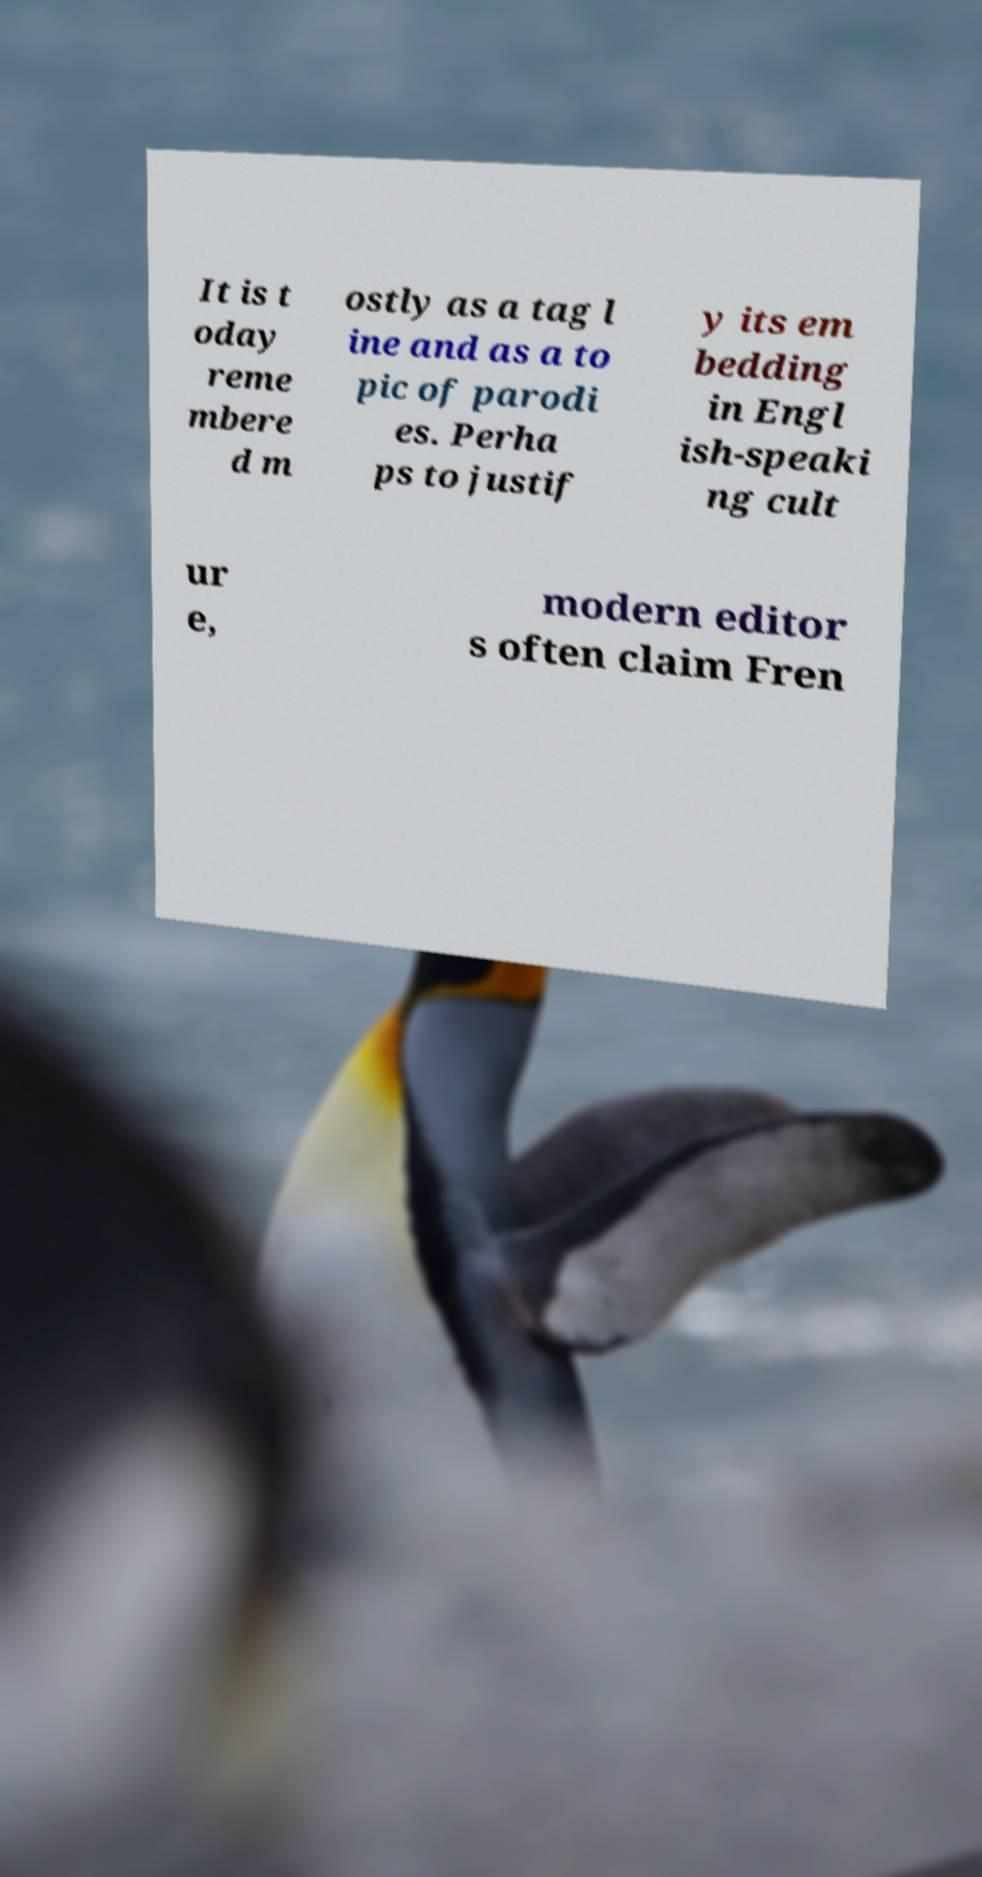Could you assist in decoding the text presented in this image and type it out clearly? It is t oday reme mbere d m ostly as a tag l ine and as a to pic of parodi es. Perha ps to justif y its em bedding in Engl ish-speaki ng cult ur e, modern editor s often claim Fren 